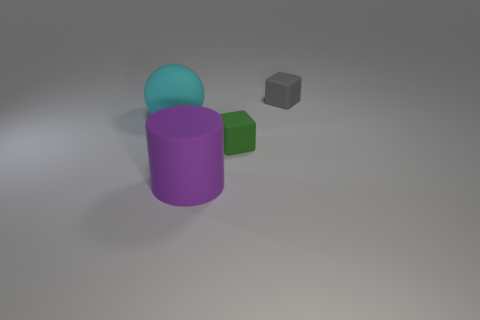Subtract all blue blocks. Subtract all green cylinders. How many blocks are left? 2 Add 1 big balls. How many objects exist? 5 Subtract all cylinders. How many objects are left? 3 Add 2 large cyan spheres. How many large cyan spheres exist? 3 Subtract 0 yellow blocks. How many objects are left? 4 Subtract all purple metallic spheres. Subtract all large purple rubber objects. How many objects are left? 3 Add 4 large spheres. How many large spheres are left? 5 